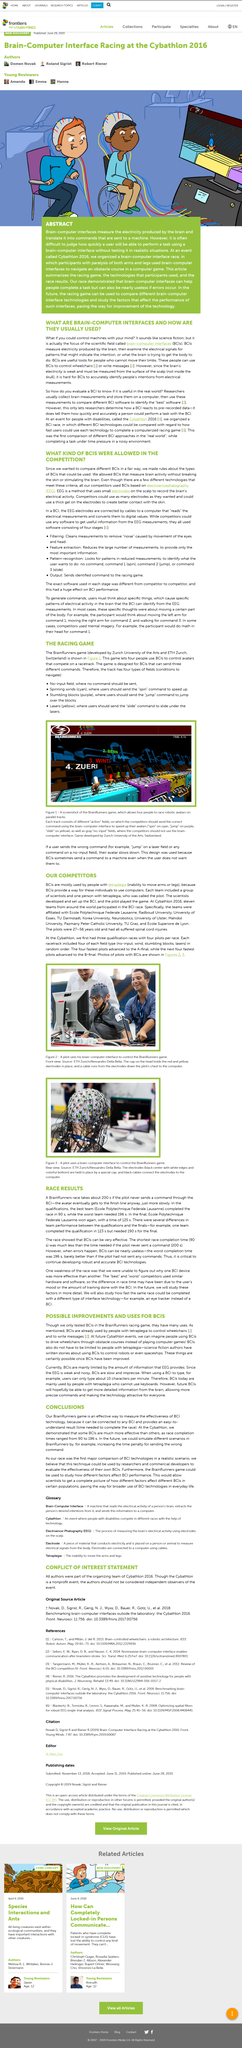Specify some key components in this picture. The BrainRunners game was developed by Zurich University of the Arts and ETH Zurich, two prestigious institutions in Switzerland. Researchers test the real-world application of a BCI by collecting and storing brain measurements on a computer and comparing different BCI software to determine which is the most effective. The electrodes on the cap in the photo are red and yellow. The man in the photo, who is wearing a cap, is a pilot. Zurich University of the Arts is located in Switzerland. 